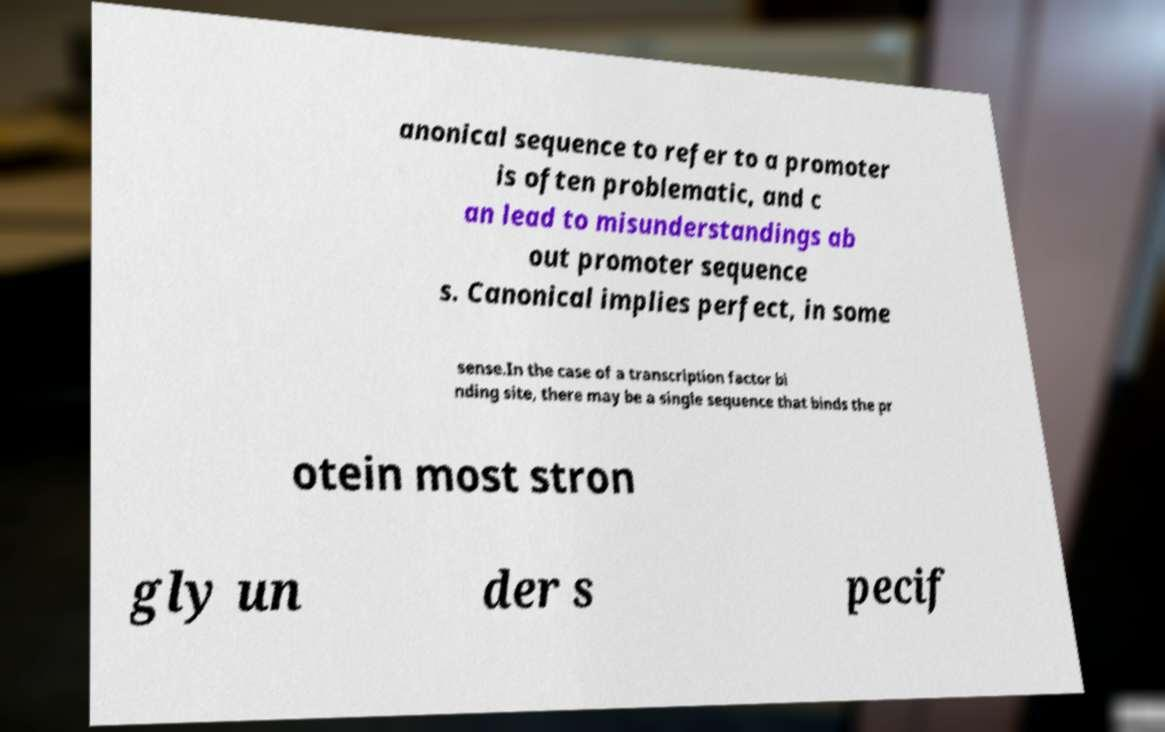Could you extract and type out the text from this image? anonical sequence to refer to a promoter is often problematic, and c an lead to misunderstandings ab out promoter sequence s. Canonical implies perfect, in some sense.In the case of a transcription factor bi nding site, there may be a single sequence that binds the pr otein most stron gly un der s pecif 